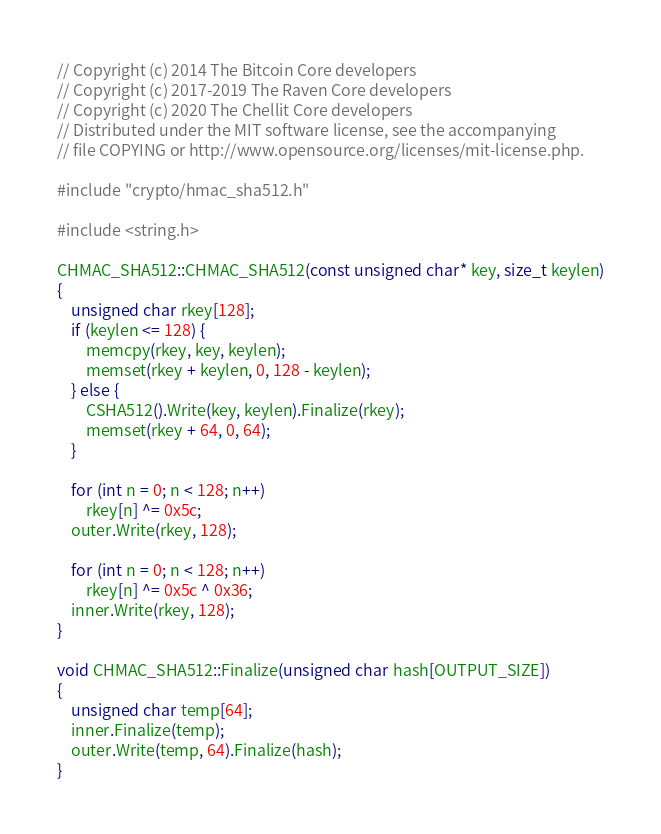<code> <loc_0><loc_0><loc_500><loc_500><_C++_>// Copyright (c) 2014 The Bitcoin Core developers
// Copyright (c) 2017-2019 The Raven Core developers
// Copyright (c) 2020 The Chellit Core developers
// Distributed under the MIT software license, see the accompanying
// file COPYING or http://www.opensource.org/licenses/mit-license.php.

#include "crypto/hmac_sha512.h"

#include <string.h>

CHMAC_SHA512::CHMAC_SHA512(const unsigned char* key, size_t keylen)
{
    unsigned char rkey[128];
    if (keylen <= 128) {
        memcpy(rkey, key, keylen);
        memset(rkey + keylen, 0, 128 - keylen);
    } else {
        CSHA512().Write(key, keylen).Finalize(rkey);
        memset(rkey + 64, 0, 64);
    }

    for (int n = 0; n < 128; n++)
        rkey[n] ^= 0x5c;
    outer.Write(rkey, 128);

    for (int n = 0; n < 128; n++)
        rkey[n] ^= 0x5c ^ 0x36;
    inner.Write(rkey, 128);
}

void CHMAC_SHA512::Finalize(unsigned char hash[OUTPUT_SIZE])
{
    unsigned char temp[64];
    inner.Finalize(temp);
    outer.Write(temp, 64).Finalize(hash);
}
</code> 